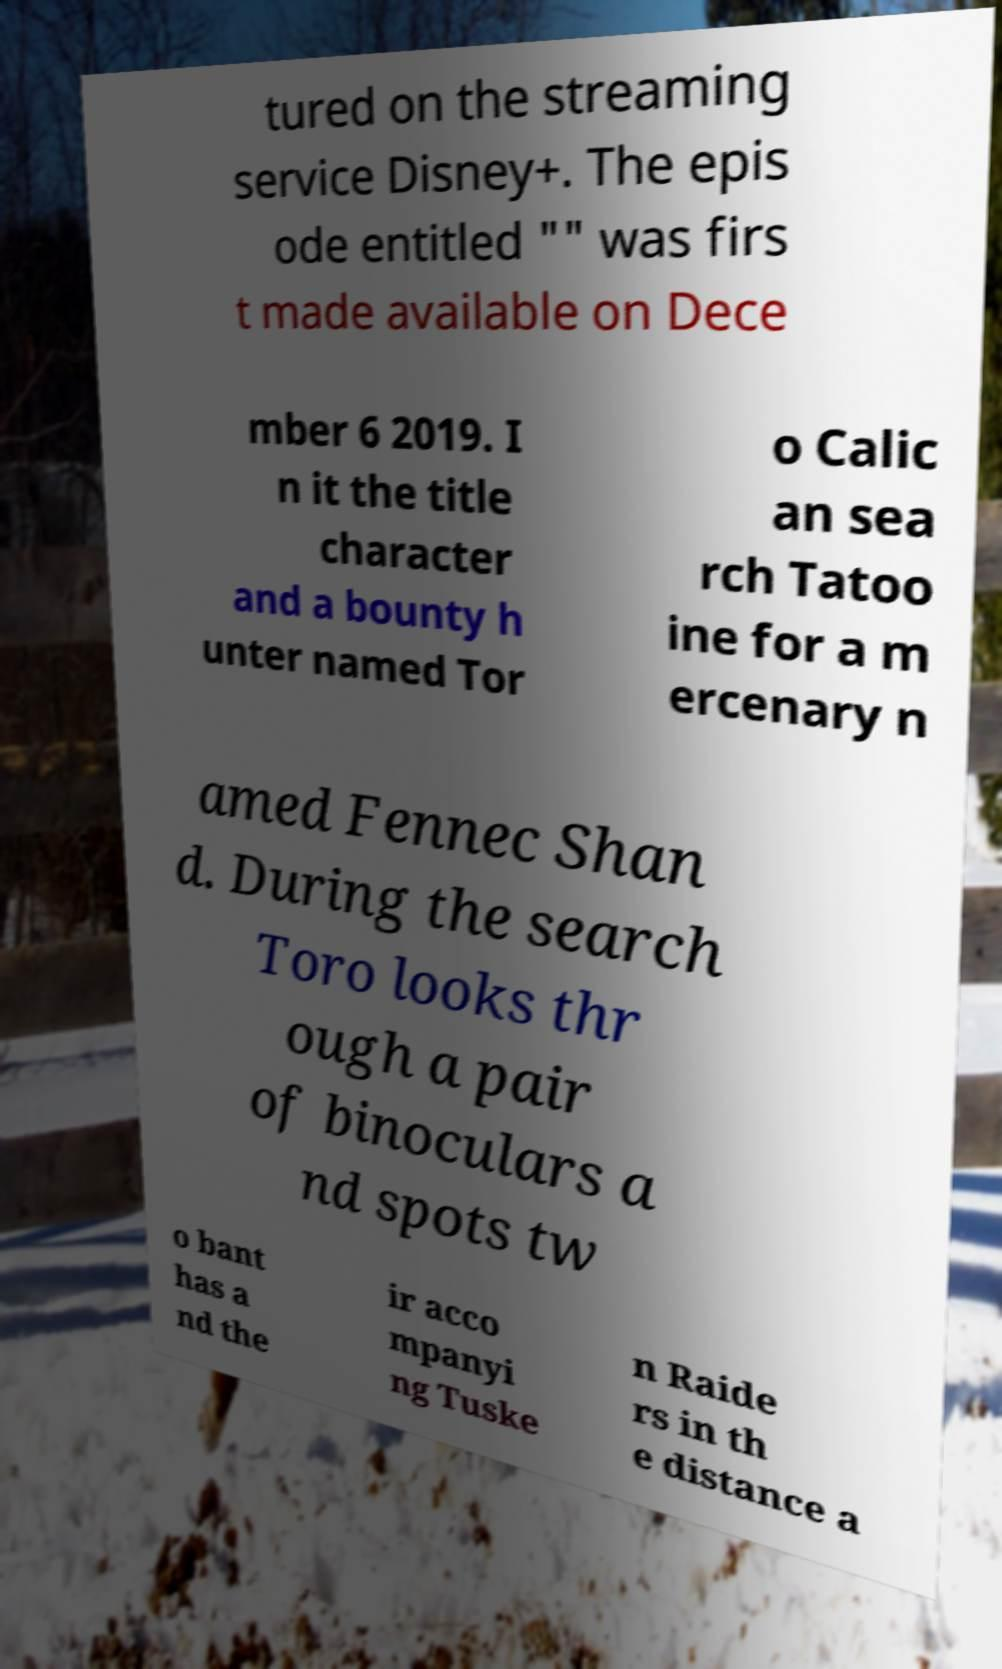I need the written content from this picture converted into text. Can you do that? tured on the streaming service Disney+. The epis ode entitled "" was firs t made available on Dece mber 6 2019. I n it the title character and a bounty h unter named Tor o Calic an sea rch Tatoo ine for a m ercenary n amed Fennec Shan d. During the search Toro looks thr ough a pair of binoculars a nd spots tw o bant has a nd the ir acco mpanyi ng Tuske n Raide rs in th e distance a 